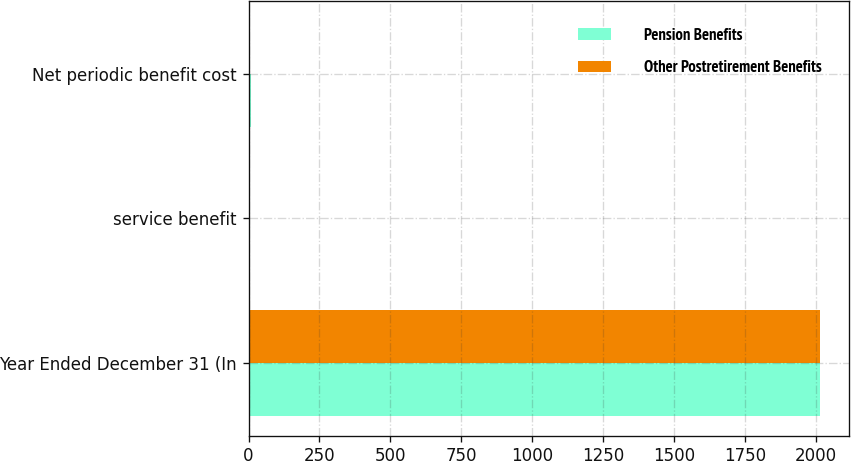Convert chart to OTSL. <chart><loc_0><loc_0><loc_500><loc_500><stacked_bar_chart><ecel><fcel>Year Ended December 31 (In<fcel>service benefit<fcel>Net periodic benefit cost<nl><fcel>Pension Benefits<fcel>2016<fcel>1<fcel>7<nl><fcel>Other Postretirement Benefits<fcel>2016<fcel>3<fcel>4<nl></chart> 